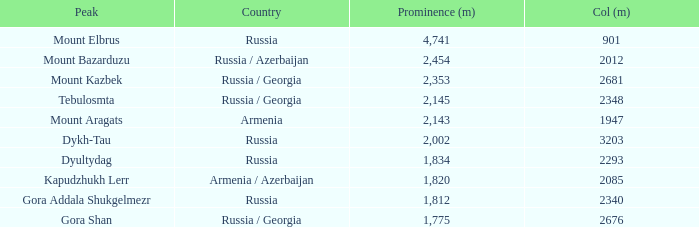With a Col (m) larger than 2012, what is Mount Kazbek's Prominence (m)? 2353.0. 